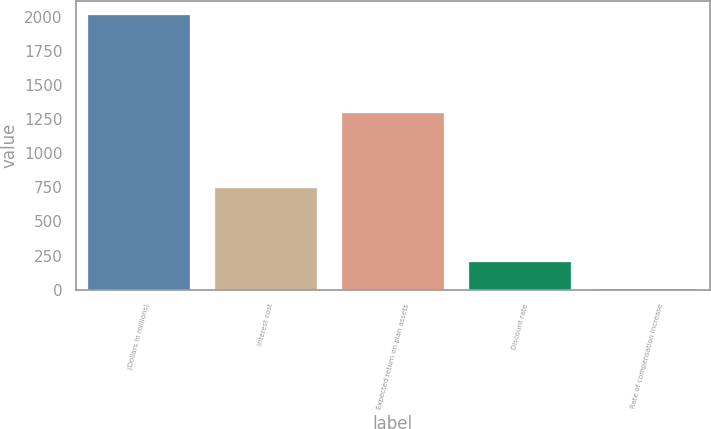Convert chart to OTSL. <chart><loc_0><loc_0><loc_500><loc_500><bar_chart><fcel>(Dollars in millions)<fcel>Interest cost<fcel>Expected return on plan assets<fcel>Discount rate<fcel>Rate of compensation increase<nl><fcel>2011<fcel>746<fcel>1296<fcel>204.7<fcel>4<nl></chart> 